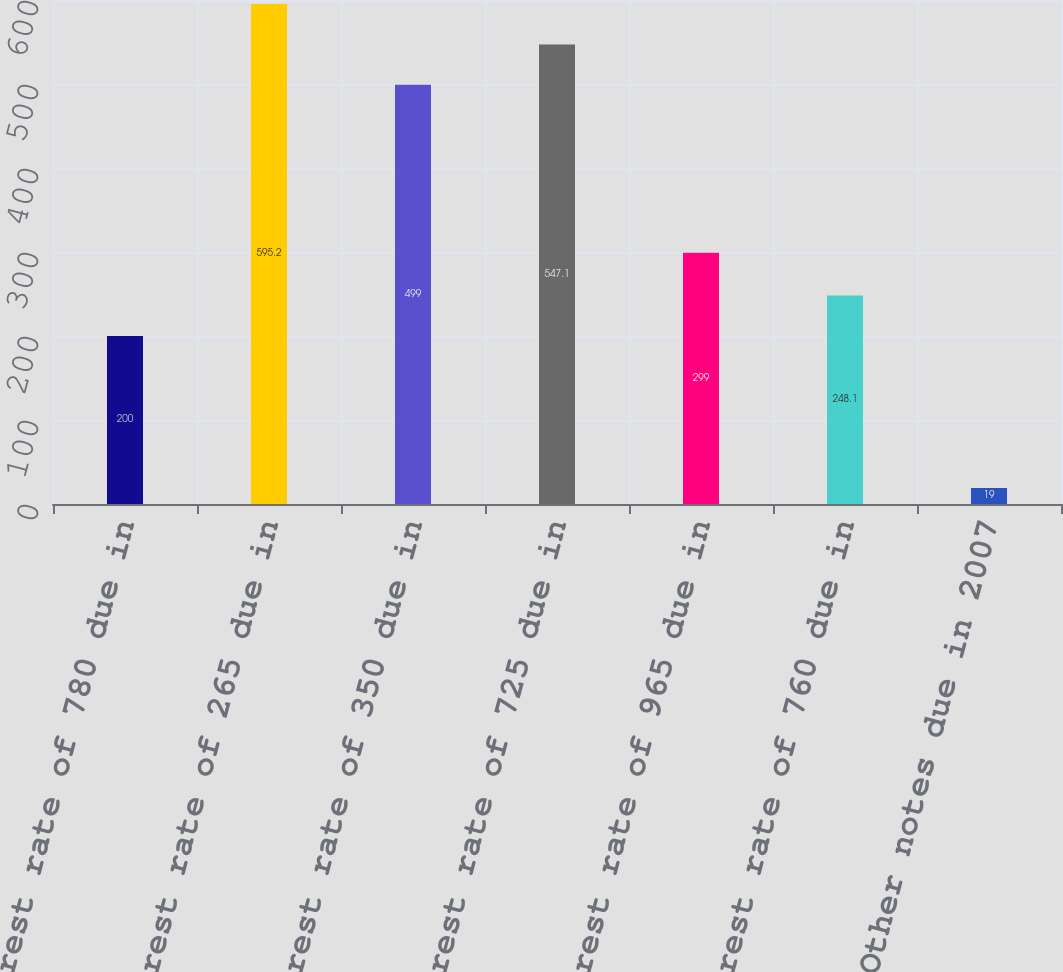Convert chart. <chart><loc_0><loc_0><loc_500><loc_500><bar_chart><fcel>Interest rate of 780 due in<fcel>Interest rate of 265 due in<fcel>Interest rate of 350 due in<fcel>Interest rate of 725 due in<fcel>Interest rate of 965 due in<fcel>Interest rate of 760 due in<fcel>Other notes due in 2007<nl><fcel>200<fcel>595.2<fcel>499<fcel>547.1<fcel>299<fcel>248.1<fcel>19<nl></chart> 